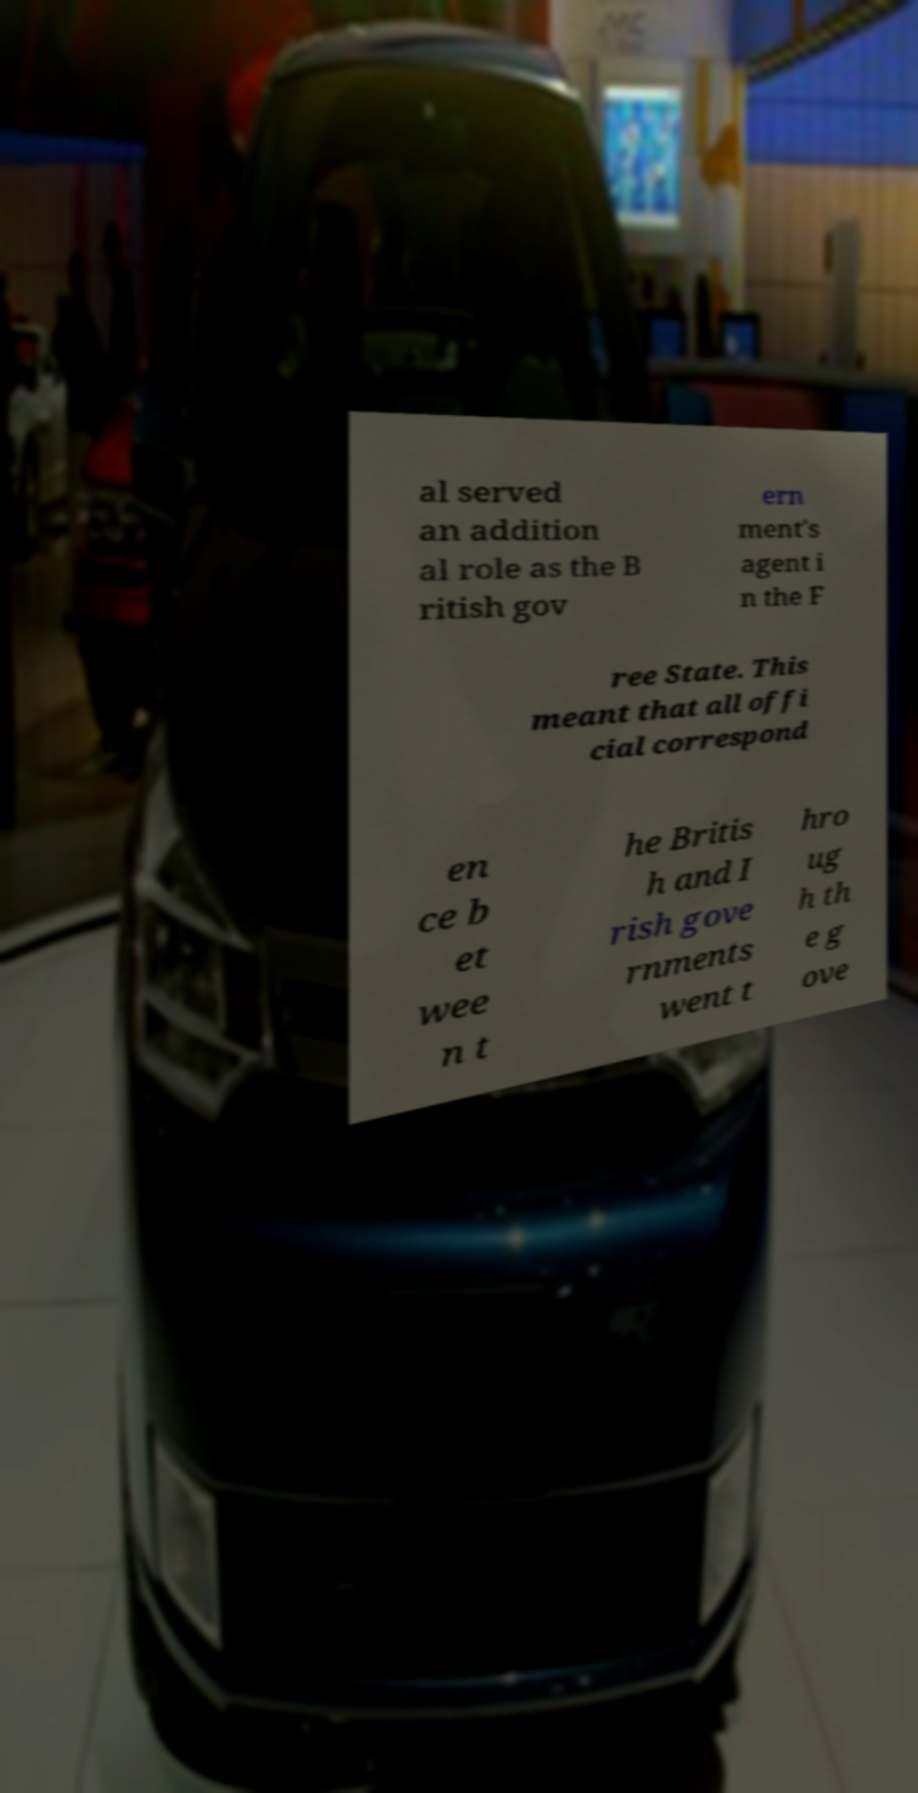I need the written content from this picture converted into text. Can you do that? al served an addition al role as the B ritish gov ern ment's agent i n the F ree State. This meant that all offi cial correspond en ce b et wee n t he Britis h and I rish gove rnments went t hro ug h th e g ove 